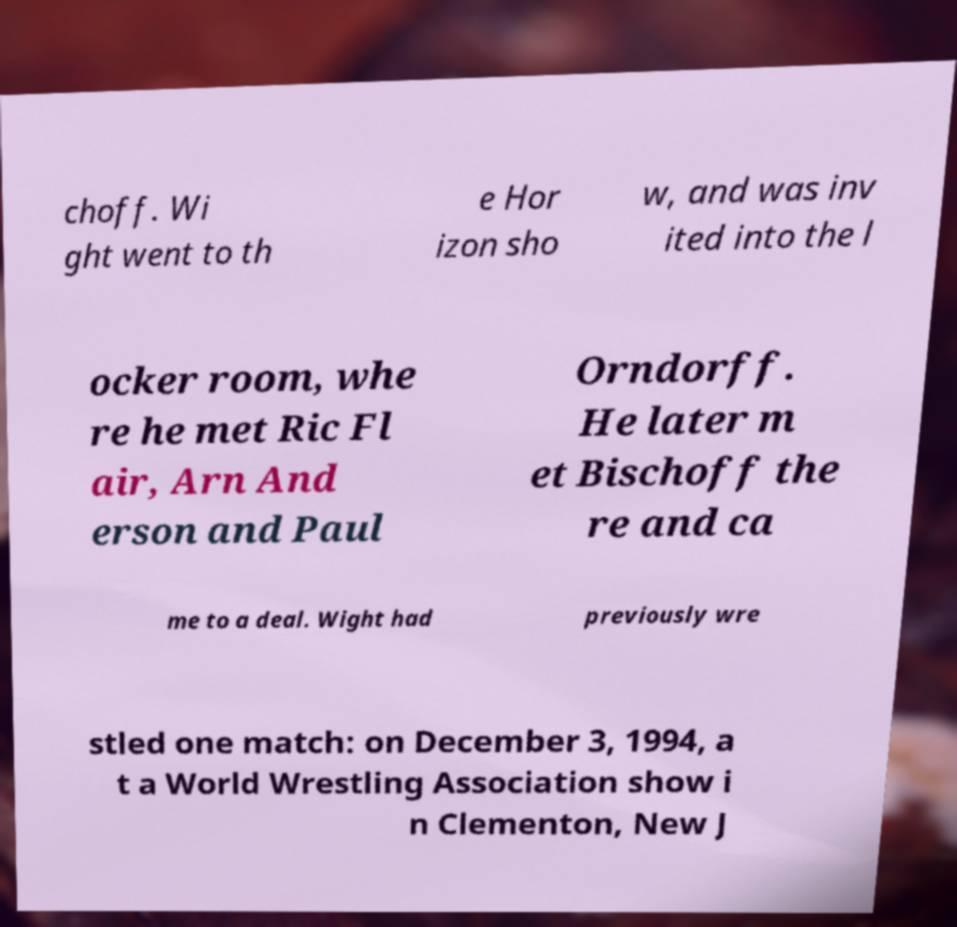Can you read and provide the text displayed in the image?This photo seems to have some interesting text. Can you extract and type it out for me? choff. Wi ght went to th e Hor izon sho w, and was inv ited into the l ocker room, whe re he met Ric Fl air, Arn And erson and Paul Orndorff. He later m et Bischoff the re and ca me to a deal. Wight had previously wre stled one match: on December 3, 1994, a t a World Wrestling Association show i n Clementon, New J 